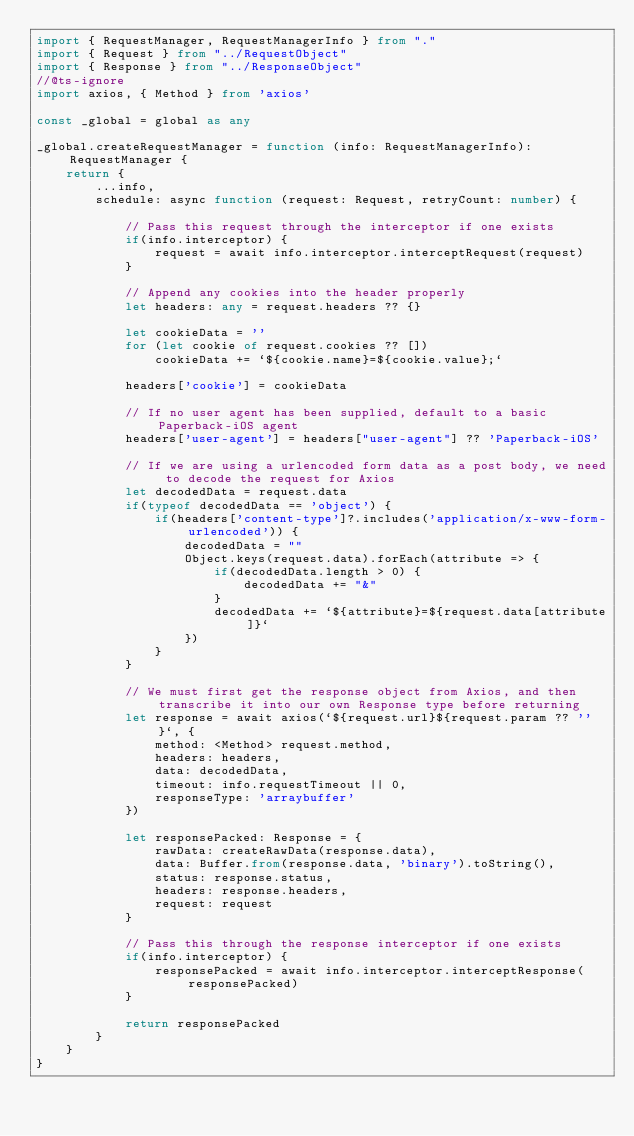<code> <loc_0><loc_0><loc_500><loc_500><_TypeScript_>import { RequestManager, RequestManagerInfo } from "."
import { Request } from "../RequestObject"
import { Response } from "../ResponseObject"
//@ts-ignore
import axios, { Method } from 'axios'

const _global = global as any

_global.createRequestManager = function (info: RequestManagerInfo): RequestManager {
    return {
        ...info,
        schedule: async function (request: Request, retryCount: number) {

            // Pass this request through the interceptor if one exists
            if(info.interceptor) {
                request = await info.interceptor.interceptRequest(request)
            }

            // Append any cookies into the header properly
            let headers: any = request.headers ?? {}

            let cookieData = ''
            for (let cookie of request.cookies ?? [])
                cookieData += `${cookie.name}=${cookie.value};`

            headers['cookie'] = cookieData

            // If no user agent has been supplied, default to a basic Paperback-iOS agent
            headers['user-agent'] = headers["user-agent"] ?? 'Paperback-iOS'

            // If we are using a urlencoded form data as a post body, we need to decode the request for Axios
            let decodedData = request.data
            if(typeof decodedData == 'object') {
                if(headers['content-type']?.includes('application/x-www-form-urlencoded')) {
                    decodedData = ""
                    Object.keys(request.data).forEach(attribute => {
                        if(decodedData.length > 0) {
                            decodedData += "&"
                        }
                        decodedData += `${attribute}=${request.data[attribute]}`
                    })
                }
            }

            // We must first get the response object from Axios, and then transcribe it into our own Response type before returning
            let response = await axios(`${request.url}${request.param ?? ''}`, {
                method: <Method> request.method,
                headers: headers,
                data: decodedData,
                timeout: info.requestTimeout || 0,
                responseType: 'arraybuffer'
            })

            let responsePacked: Response = {
                rawData: createRawData(response.data),
                data: Buffer.from(response.data, 'binary').toString(),
                status: response.status,
                headers: response.headers,
                request: request
            } 

            // Pass this through the response interceptor if one exists
            if(info.interceptor) {
                responsePacked = await info.interceptor.interceptResponse(responsePacked)
            }

            return responsePacked
        }
    }
}</code> 